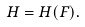Convert formula to latex. <formula><loc_0><loc_0><loc_500><loc_500>H = H ( F ) .</formula> 